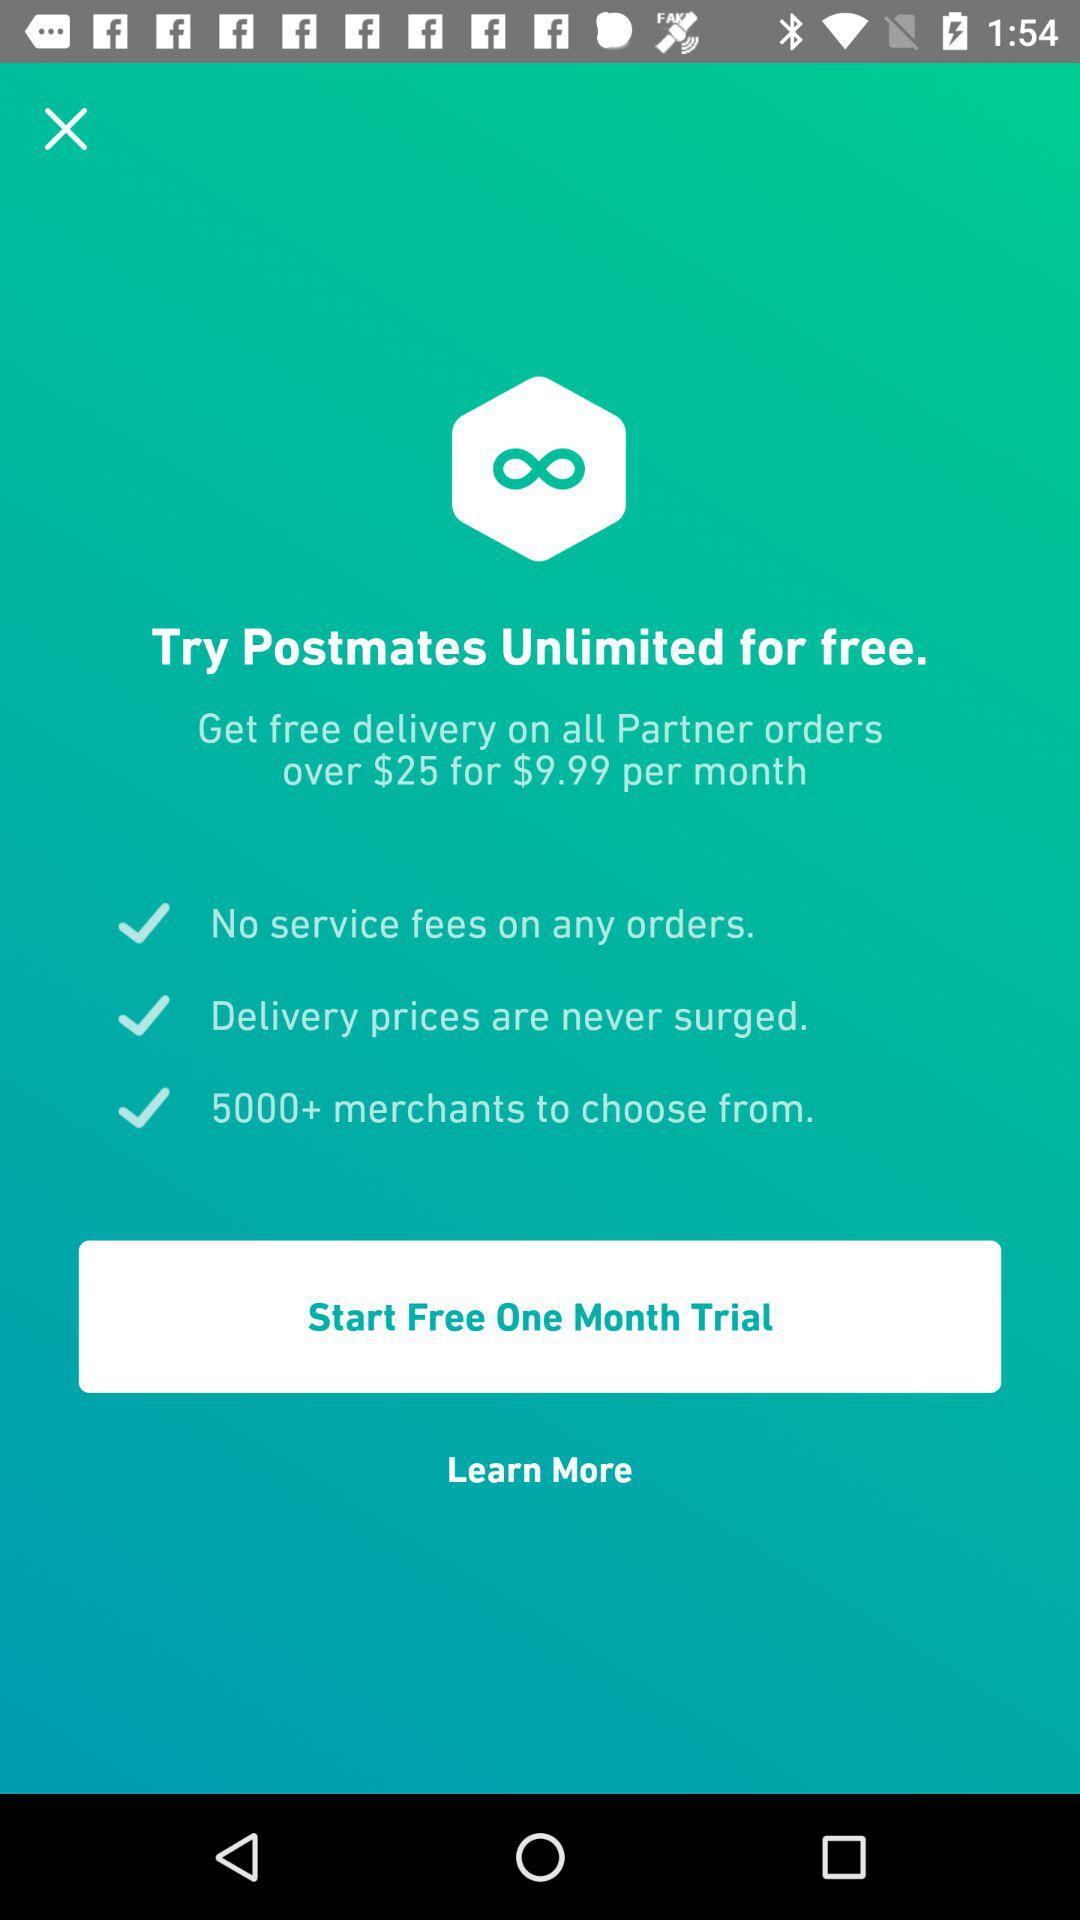Is there any service fees on any orders? There are no service fees on any orders. 